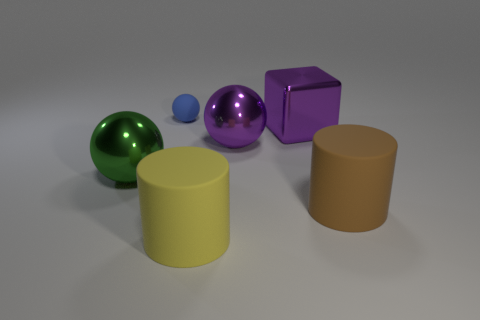Subtract all metallic spheres. How many spheres are left? 1 Add 1 tiny cylinders. How many objects exist? 7 Subtract all blue balls. How many balls are left? 2 Subtract 1 cylinders. How many cylinders are left? 1 Subtract all big yellow matte cylinders. Subtract all cubes. How many objects are left? 4 Add 2 blue balls. How many blue balls are left? 3 Add 6 rubber cylinders. How many rubber cylinders exist? 8 Subtract 0 blue cylinders. How many objects are left? 6 Subtract all cubes. How many objects are left? 5 Subtract all blue cylinders. Subtract all green blocks. How many cylinders are left? 2 